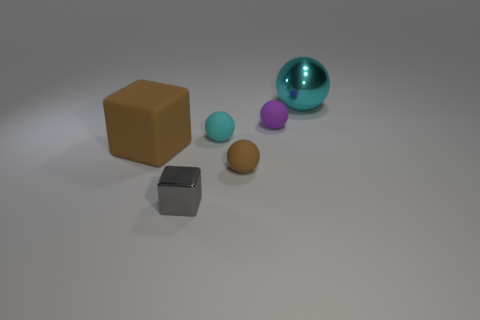Add 2 green spheres. How many objects exist? 8 Subtract all spheres. How many objects are left? 2 Subtract 0 gray balls. How many objects are left? 6 Subtract all tiny gray cubes. Subtract all gray objects. How many objects are left? 4 Add 1 small shiny cubes. How many small shiny cubes are left? 2 Add 6 large brown cylinders. How many large brown cylinders exist? 6 